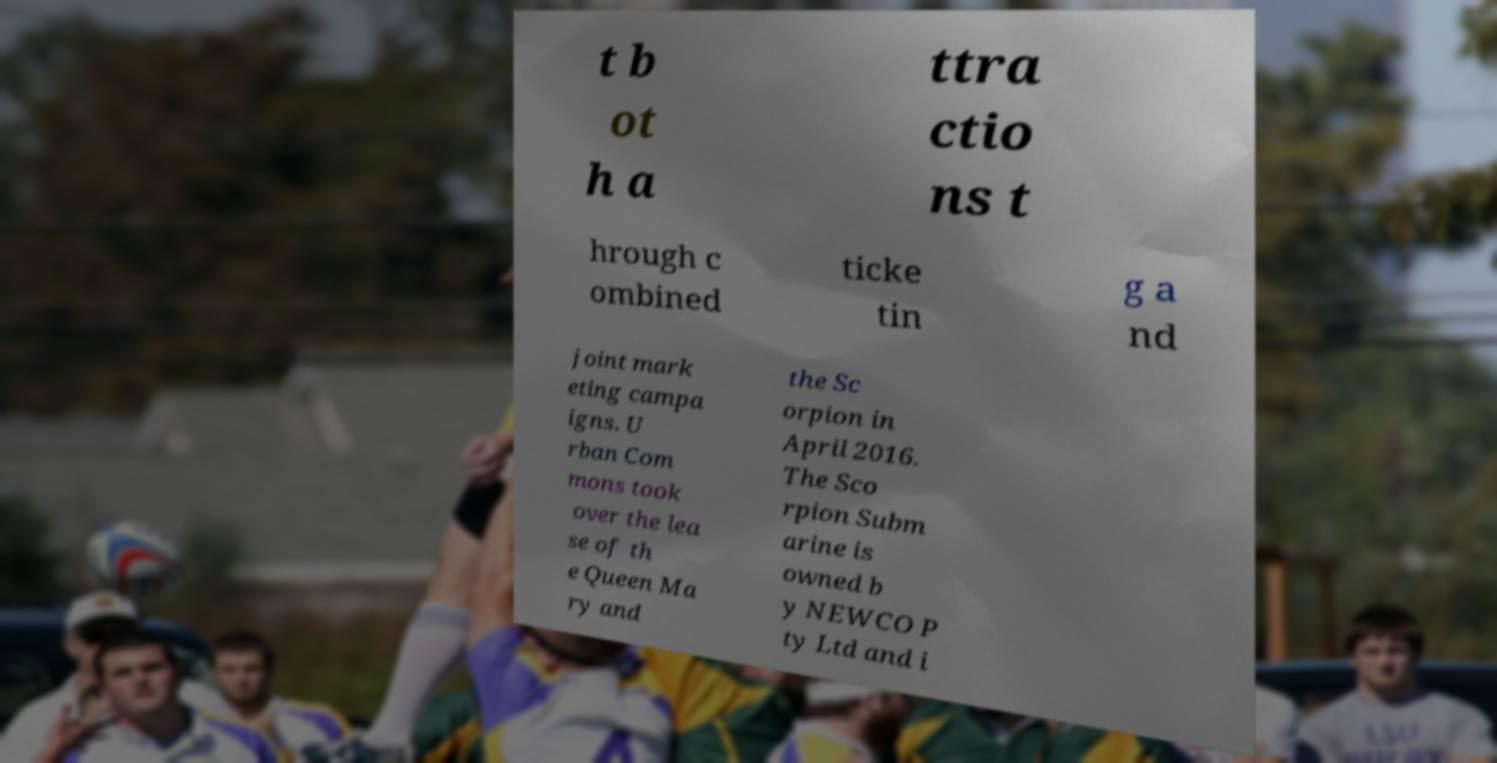Could you extract and type out the text from this image? t b ot h a ttra ctio ns t hrough c ombined ticke tin g a nd joint mark eting campa igns. U rban Com mons took over the lea se of th e Queen Ma ry and the Sc orpion in April 2016. The Sco rpion Subm arine is owned b y NEWCO P ty Ltd and i 